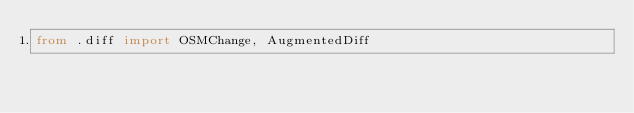<code> <loc_0><loc_0><loc_500><loc_500><_Python_>from .diff import OSMChange, AugmentedDiff</code> 